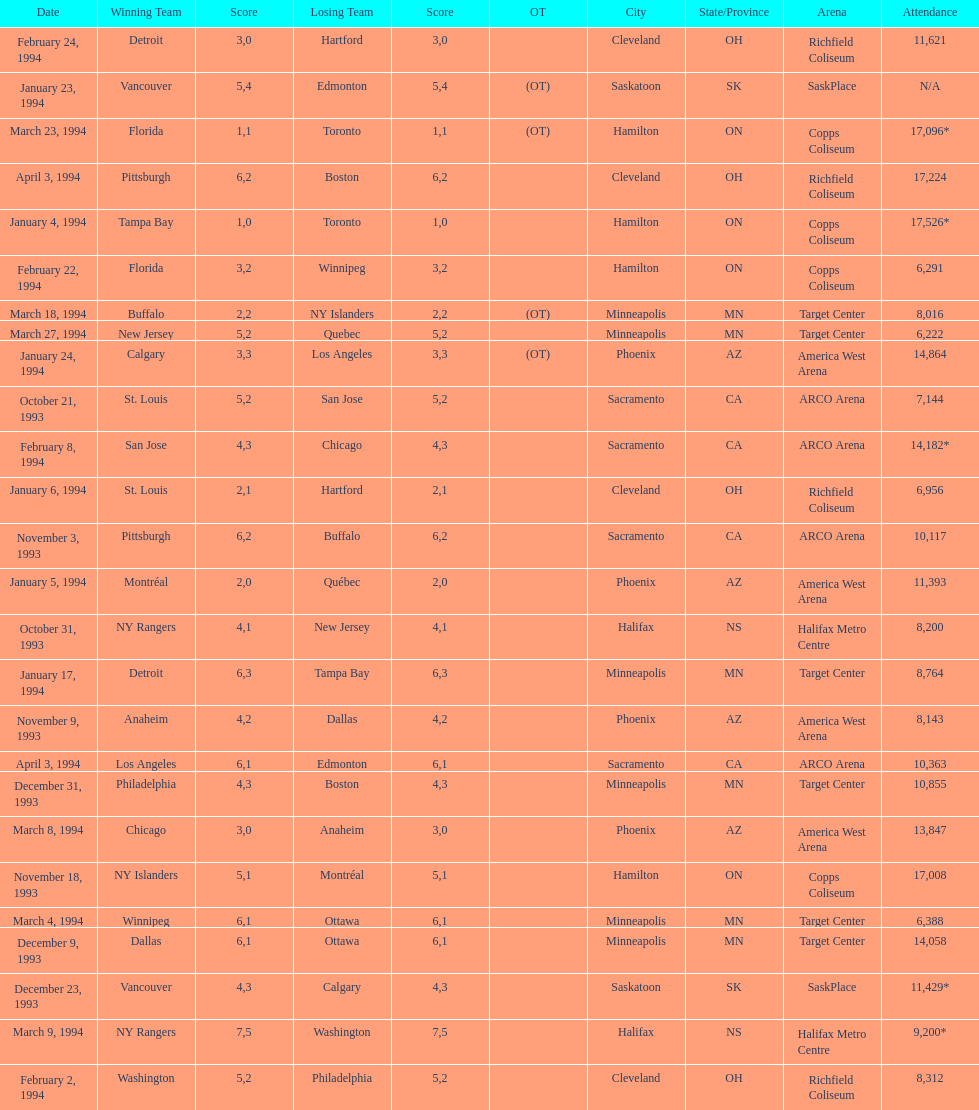When was the first time tampa bay emerged victorious in a neutral site game? January 4, 1994. 